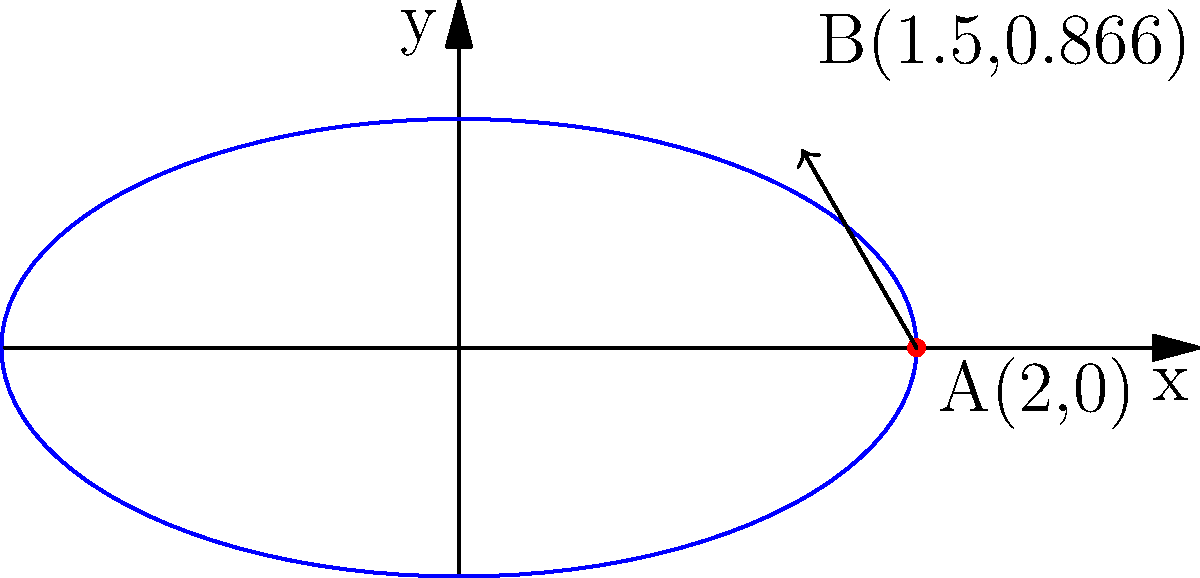A particle moves along the curve defined by the parametric equations $x=2\cos t$ and $y=\sin t$. At the point A(2,0), which corresponds to $t=0$, the particle is moving towards point B(1.5, 0.866). Calculate the rate of change of the particle's y-coordinate with respect to its x-coordinate at point A. To find the rate of change of y with respect to x, we need to calculate $\frac{dy}{dx}$ at point A. We can do this using the chain rule:

1) First, we calculate $\frac{dx}{dt}$ and $\frac{dy}{dt}$:
   $\frac{dx}{dt} = -2\sin t$
   $\frac{dy}{dt} = \cos t$

2) Then, we use the chain rule: $\frac{dy}{dx} = \frac{dy/dt}{dx/dt}$

3) At point A, $t=0$. Substituting this:
   $\frac{dy}{dx}|_{t=0} = \frac{\cos 0}{-2\sin 0}$

4) Simplify:
   $\frac{dy}{dx}|_{t=0} = \frac{1}{0}$

5) This result is undefined, indicating a vertical tangent line. However, we know the particle is moving towards point B, not vertically.

6) To resolve this, we can use the limit as t approaches 0:
   $\lim_{t \to 0} \frac{dy}{dx} = \lim_{t \to 0} \frac{\cos t}{-2\sin t}$

7) Apply L'Hôpital's rule:
   $\lim_{t \to 0} \frac{-\sin t}{-2\cos t} = \lim_{t \to 0} \frac{\sin t}{2\cos t} = 0$

Therefore, the rate of change of y with respect to x at point A is 0.
Answer: 0 